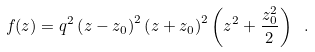Convert formula to latex. <formula><loc_0><loc_0><loc_500><loc_500>f ( z ) = q ^ { 2 } \left ( z - z _ { 0 } \right ) ^ { 2 } \left ( z + z _ { 0 } \right ) ^ { 2 } \left ( z ^ { 2 } + \frac { z _ { 0 } ^ { 2 } } { 2 } \right ) \ .</formula> 